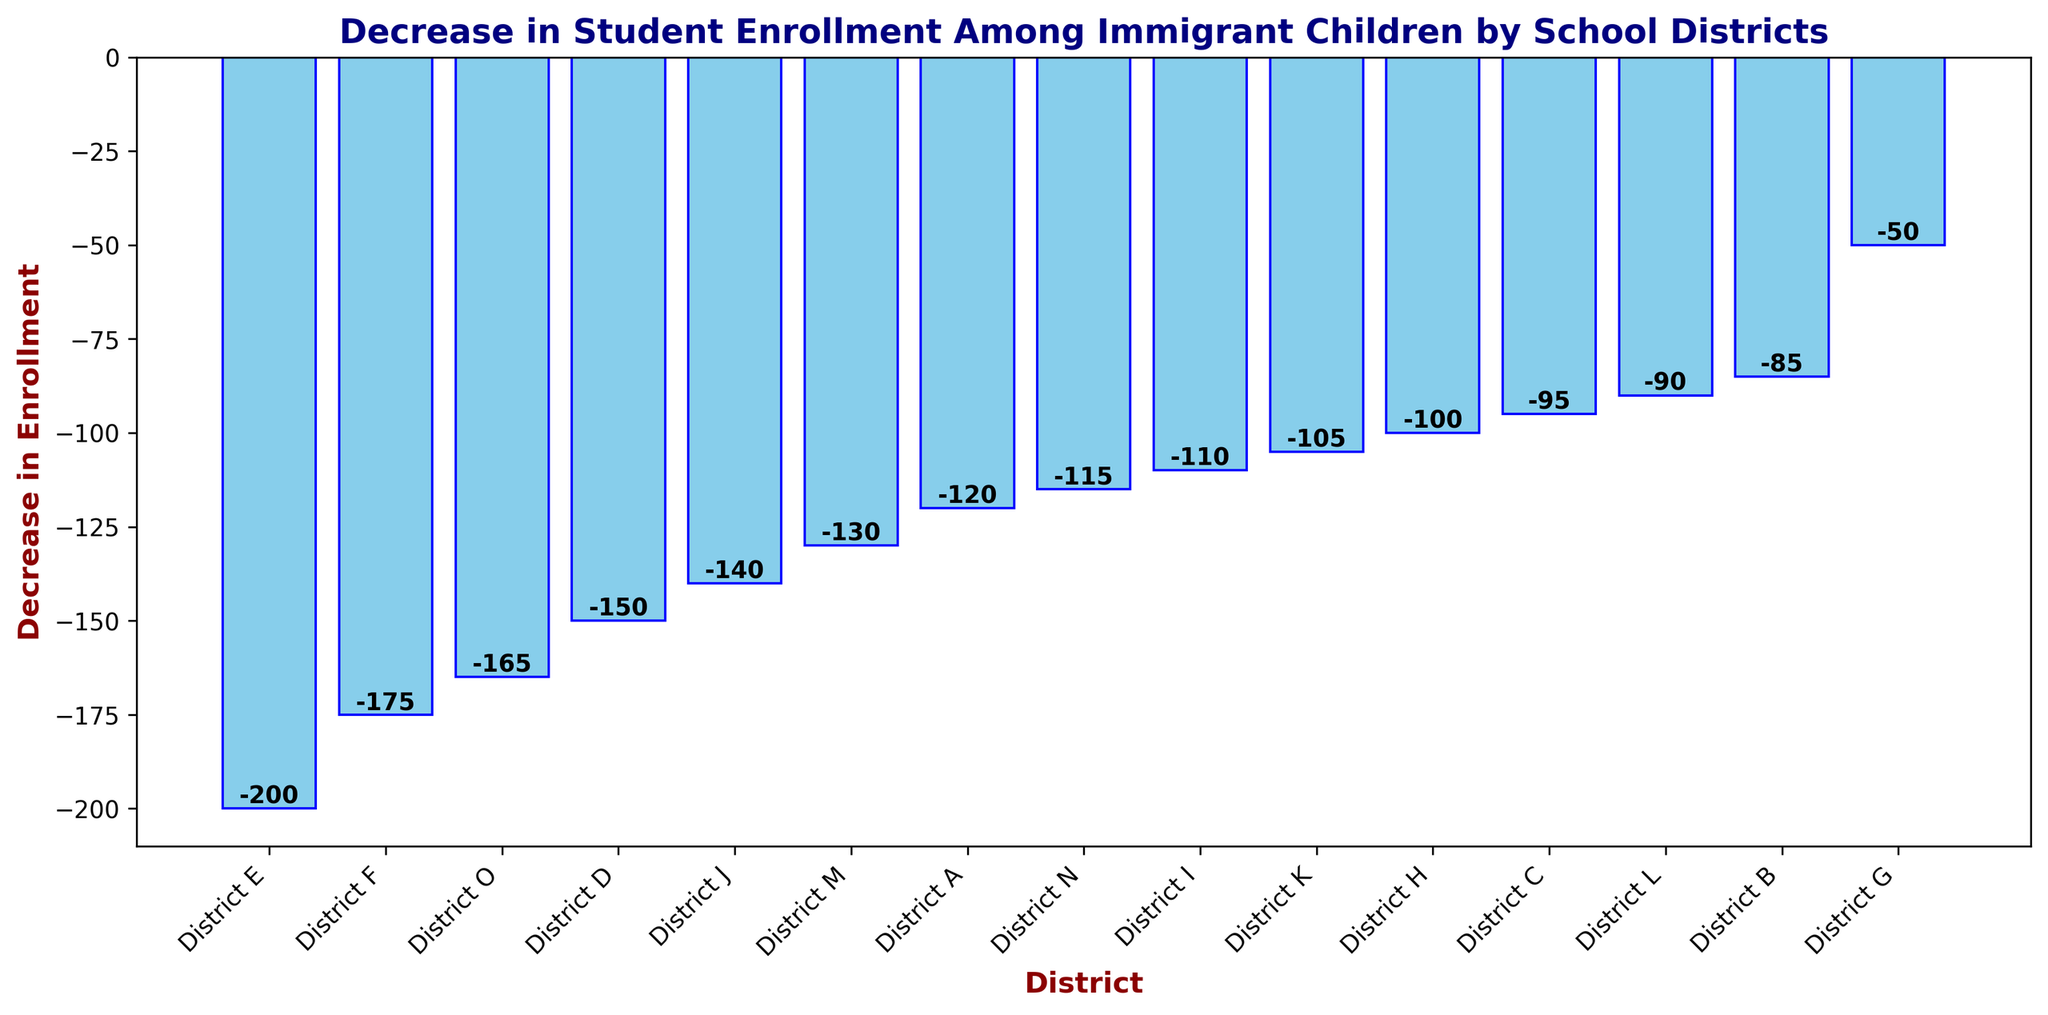Which district has the highest decrease in student enrollment? By looking at the bar representing each district, the one with the longest bar (most negative value) indicates the highest decrease. In this case, District E has the longest bar.
Answer: District E Which district has the least decrease in student enrollment? By examining the bar lengths, the district with the shortest bar (least negative value) has the least decrease. District G has the shortest bar.
Answer: District G What is the difference in enrollment decrease between District E and District A? District E has a decrease of -200, and District A has a decrease of -120. The difference is calculated as -200 - (-120) = -80.
Answer: 80 Are there more districts with a decrease greater than 100 or less than 100? There are 9 districts (B, C, D, F, H, I, J, K, M, N, O) with a decrease greater than 100 and 6 (A, G, L) with a decrease less than 100.
Answer: Greater than 100 Which districts have a decrease in enrollment between 100 and 150? By scanning the figure, Districts I, J, K, H, and M fall within the range of -100 to -150.
Answer: Districts I, J, K, H, M What is the total decrease in enrollment for Districts D, F, and O combined? District D: -150, District F: -175, District O: -165. The total decrease is -150 + -175 + -165 = -490.
Answer: -490 Is the enrollment decrease of District L greater than that of District C? District L has a decrease of -90 and District C has a decrease of -95. District L's bar is shorter (less negative).
Answer: No What's the average enrollment decrease among all districts? Sum all decreases: -120 + -85 + -95 + -150 + -200 + -175 + -50 + -100 + -110 + -140 + -105 + -90 + -130 + -115 + -165 = -1925. There are 15 districts, so average is -1925 / 15 = -128.33.
Answer: -128.33 Which bars are colored skyblue? All bars representing each district are colored skyblue as indicated by the description of the figure.
Answer: All How many districts show a decrease greater than 150? By examining the bar lengths, District D, E, F, and O have decreases greater than 150.
Answer: 4 